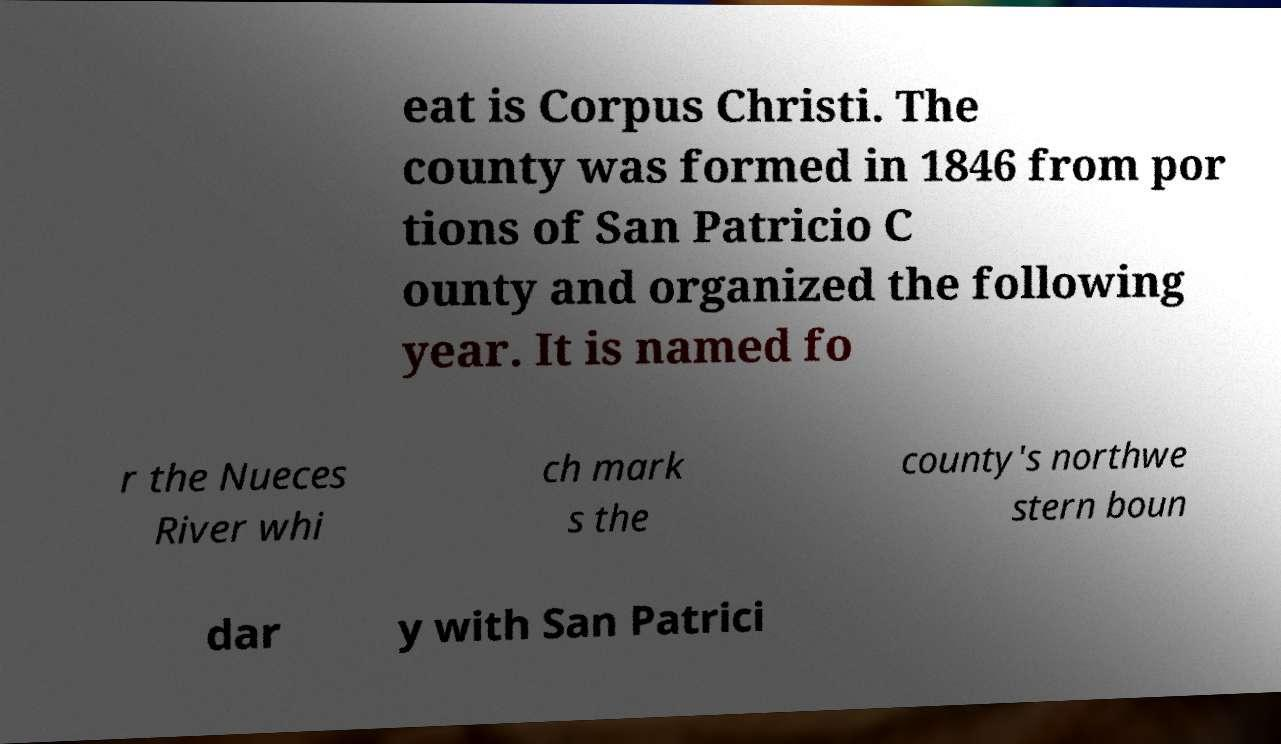Could you extract and type out the text from this image? eat is Corpus Christi. The county was formed in 1846 from por tions of San Patricio C ounty and organized the following year. It is named fo r the Nueces River whi ch mark s the county's northwe stern boun dar y with San Patrici 